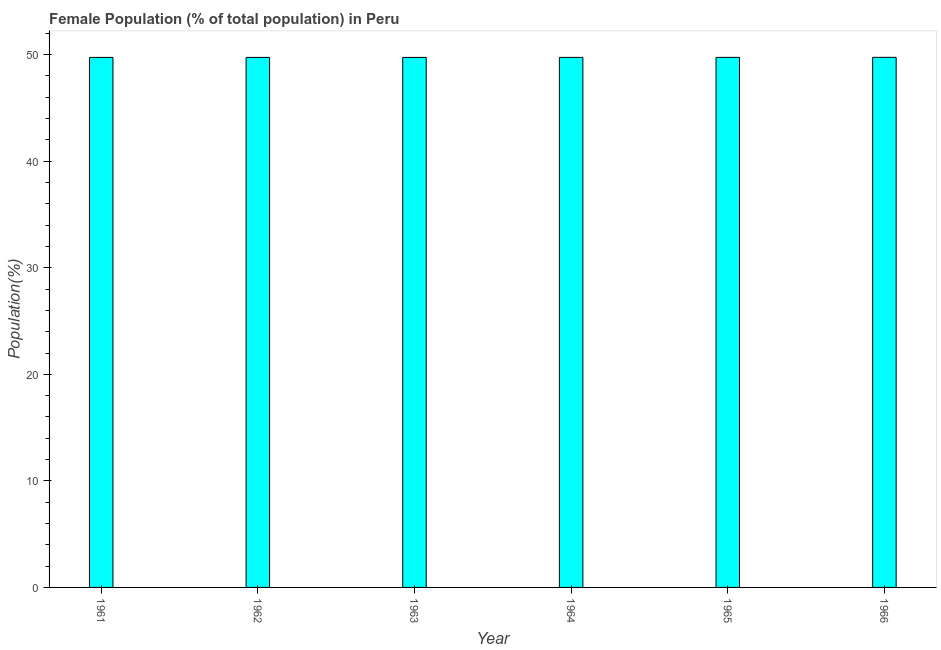Does the graph contain any zero values?
Make the answer very short. No. What is the title of the graph?
Your answer should be very brief. Female Population (% of total population) in Peru. What is the label or title of the Y-axis?
Your answer should be compact. Population(%). What is the female population in 1963?
Give a very brief answer. 49.74. Across all years, what is the maximum female population?
Offer a very short reply. 49.75. Across all years, what is the minimum female population?
Provide a succinct answer. 49.74. In which year was the female population maximum?
Your answer should be very brief. 1966. In which year was the female population minimum?
Offer a very short reply. 1962. What is the sum of the female population?
Provide a succinct answer. 298.46. What is the average female population per year?
Offer a very short reply. 49.74. What is the median female population?
Make the answer very short. 49.74. What is the difference between the highest and the second highest female population?
Your response must be concise. 0. What is the difference between the highest and the lowest female population?
Offer a very short reply. 0.01. In how many years, is the female population greater than the average female population taken over all years?
Provide a short and direct response. 2. How many years are there in the graph?
Make the answer very short. 6. What is the Population(%) of 1961?
Keep it short and to the point. 49.74. What is the Population(%) in 1962?
Your answer should be compact. 49.74. What is the Population(%) of 1963?
Make the answer very short. 49.74. What is the Population(%) of 1964?
Give a very brief answer. 49.74. What is the Population(%) in 1965?
Provide a succinct answer. 49.74. What is the Population(%) of 1966?
Give a very brief answer. 49.75. What is the difference between the Population(%) in 1961 and 1962?
Give a very brief answer. 0. What is the difference between the Population(%) in 1961 and 1963?
Your answer should be very brief. -0. What is the difference between the Population(%) in 1961 and 1964?
Offer a very short reply. -0. What is the difference between the Population(%) in 1961 and 1965?
Keep it short and to the point. -0. What is the difference between the Population(%) in 1961 and 1966?
Ensure brevity in your answer.  -0.01. What is the difference between the Population(%) in 1962 and 1963?
Provide a short and direct response. -0. What is the difference between the Population(%) in 1962 and 1964?
Offer a very short reply. -0. What is the difference between the Population(%) in 1962 and 1965?
Make the answer very short. -0. What is the difference between the Population(%) in 1962 and 1966?
Offer a terse response. -0.01. What is the difference between the Population(%) in 1963 and 1964?
Provide a short and direct response. -0. What is the difference between the Population(%) in 1963 and 1965?
Offer a very short reply. -0. What is the difference between the Population(%) in 1963 and 1966?
Ensure brevity in your answer.  -0.01. What is the difference between the Population(%) in 1964 and 1965?
Provide a succinct answer. -0. What is the difference between the Population(%) in 1964 and 1966?
Keep it short and to the point. -0.01. What is the difference between the Population(%) in 1965 and 1966?
Keep it short and to the point. -0. What is the ratio of the Population(%) in 1961 to that in 1965?
Offer a terse response. 1. What is the ratio of the Population(%) in 1961 to that in 1966?
Make the answer very short. 1. What is the ratio of the Population(%) in 1962 to that in 1963?
Keep it short and to the point. 1. What is the ratio of the Population(%) in 1962 to that in 1964?
Keep it short and to the point. 1. What is the ratio of the Population(%) in 1963 to that in 1965?
Your answer should be very brief. 1. What is the ratio of the Population(%) in 1964 to that in 1965?
Provide a succinct answer. 1. What is the ratio of the Population(%) in 1965 to that in 1966?
Your answer should be very brief. 1. 